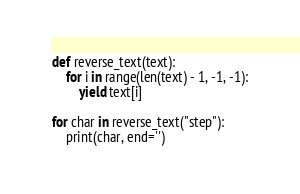<code> <loc_0><loc_0><loc_500><loc_500><_Python_>def reverse_text(text):
    for i in range(len(text) - 1, -1, -1):
        yield text[i]

for char in reverse_text("step"):
    print(char, end='')</code> 